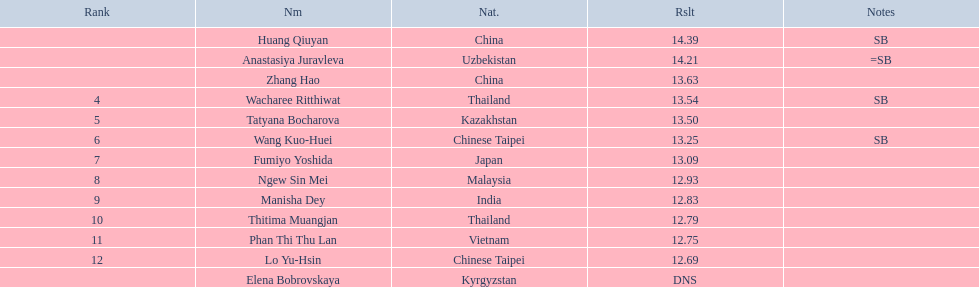How many athletes were from china? 2. 